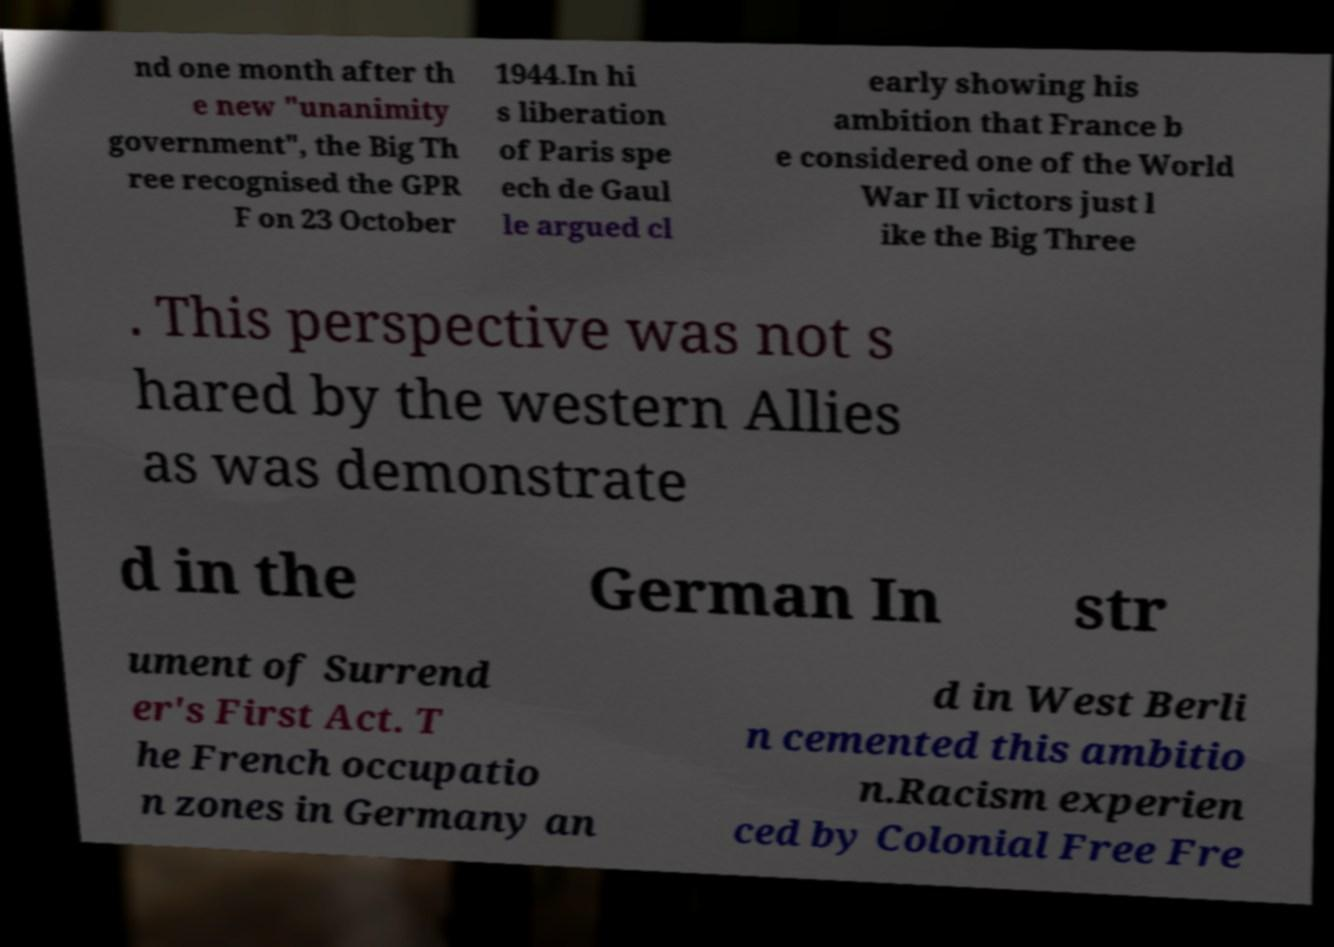There's text embedded in this image that I need extracted. Can you transcribe it verbatim? nd one month after th e new "unanimity government", the Big Th ree recognised the GPR F on 23 October 1944.In hi s liberation of Paris spe ech de Gaul le argued cl early showing his ambition that France b e considered one of the World War II victors just l ike the Big Three . This perspective was not s hared by the western Allies as was demonstrate d in the German In str ument of Surrend er's First Act. T he French occupatio n zones in Germany an d in West Berli n cemented this ambitio n.Racism experien ced by Colonial Free Fre 